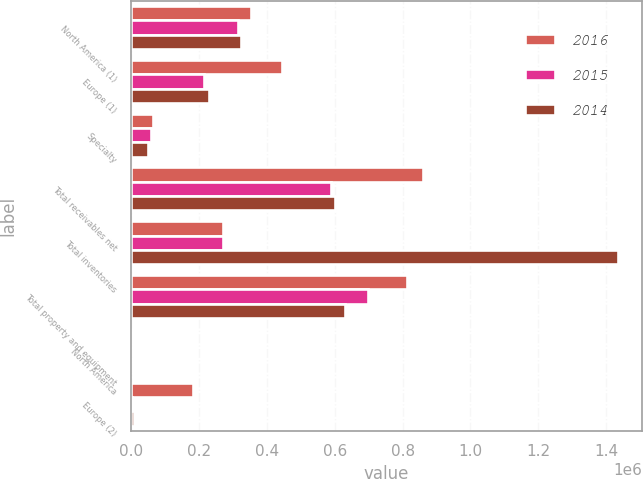Convert chart. <chart><loc_0><loc_0><loc_500><loc_500><stacked_bar_chart><ecel><fcel>North America (1)<fcel>Europe (1)<fcel>Specialty<fcel>Total receivables net<fcel>Total inventories<fcel>Total property and equipment<fcel>North America<fcel>Europe (2)<nl><fcel>2016<fcel>352930<fcel>443281<fcel>64338<fcel>860549<fcel>271365<fcel>811576<fcel>336<fcel>183131<nl><fcel>2015<fcel>314743<fcel>215710<fcel>59707<fcel>590160<fcel>271365<fcel>696567<fcel>628<fcel>2127<nl><fcel>2014<fcel>322713<fcel>227987<fcel>50722<fcel>601422<fcel>1.43385e+06<fcel>629987<fcel>536<fcel>7592<nl></chart> 